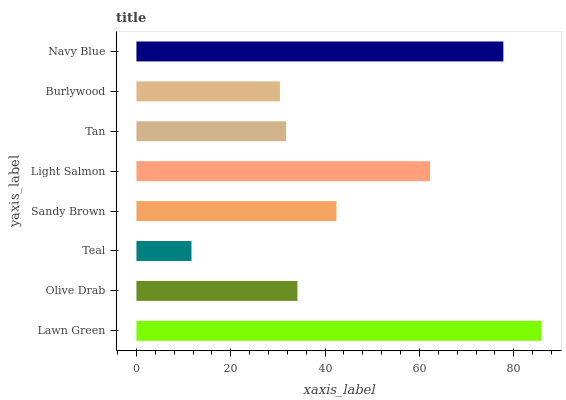Is Teal the minimum?
Answer yes or no. Yes. Is Lawn Green the maximum?
Answer yes or no. Yes. Is Olive Drab the minimum?
Answer yes or no. No. Is Olive Drab the maximum?
Answer yes or no. No. Is Lawn Green greater than Olive Drab?
Answer yes or no. Yes. Is Olive Drab less than Lawn Green?
Answer yes or no. Yes. Is Olive Drab greater than Lawn Green?
Answer yes or no. No. Is Lawn Green less than Olive Drab?
Answer yes or no. No. Is Sandy Brown the high median?
Answer yes or no. Yes. Is Olive Drab the low median?
Answer yes or no. Yes. Is Navy Blue the high median?
Answer yes or no. No. Is Burlywood the low median?
Answer yes or no. No. 